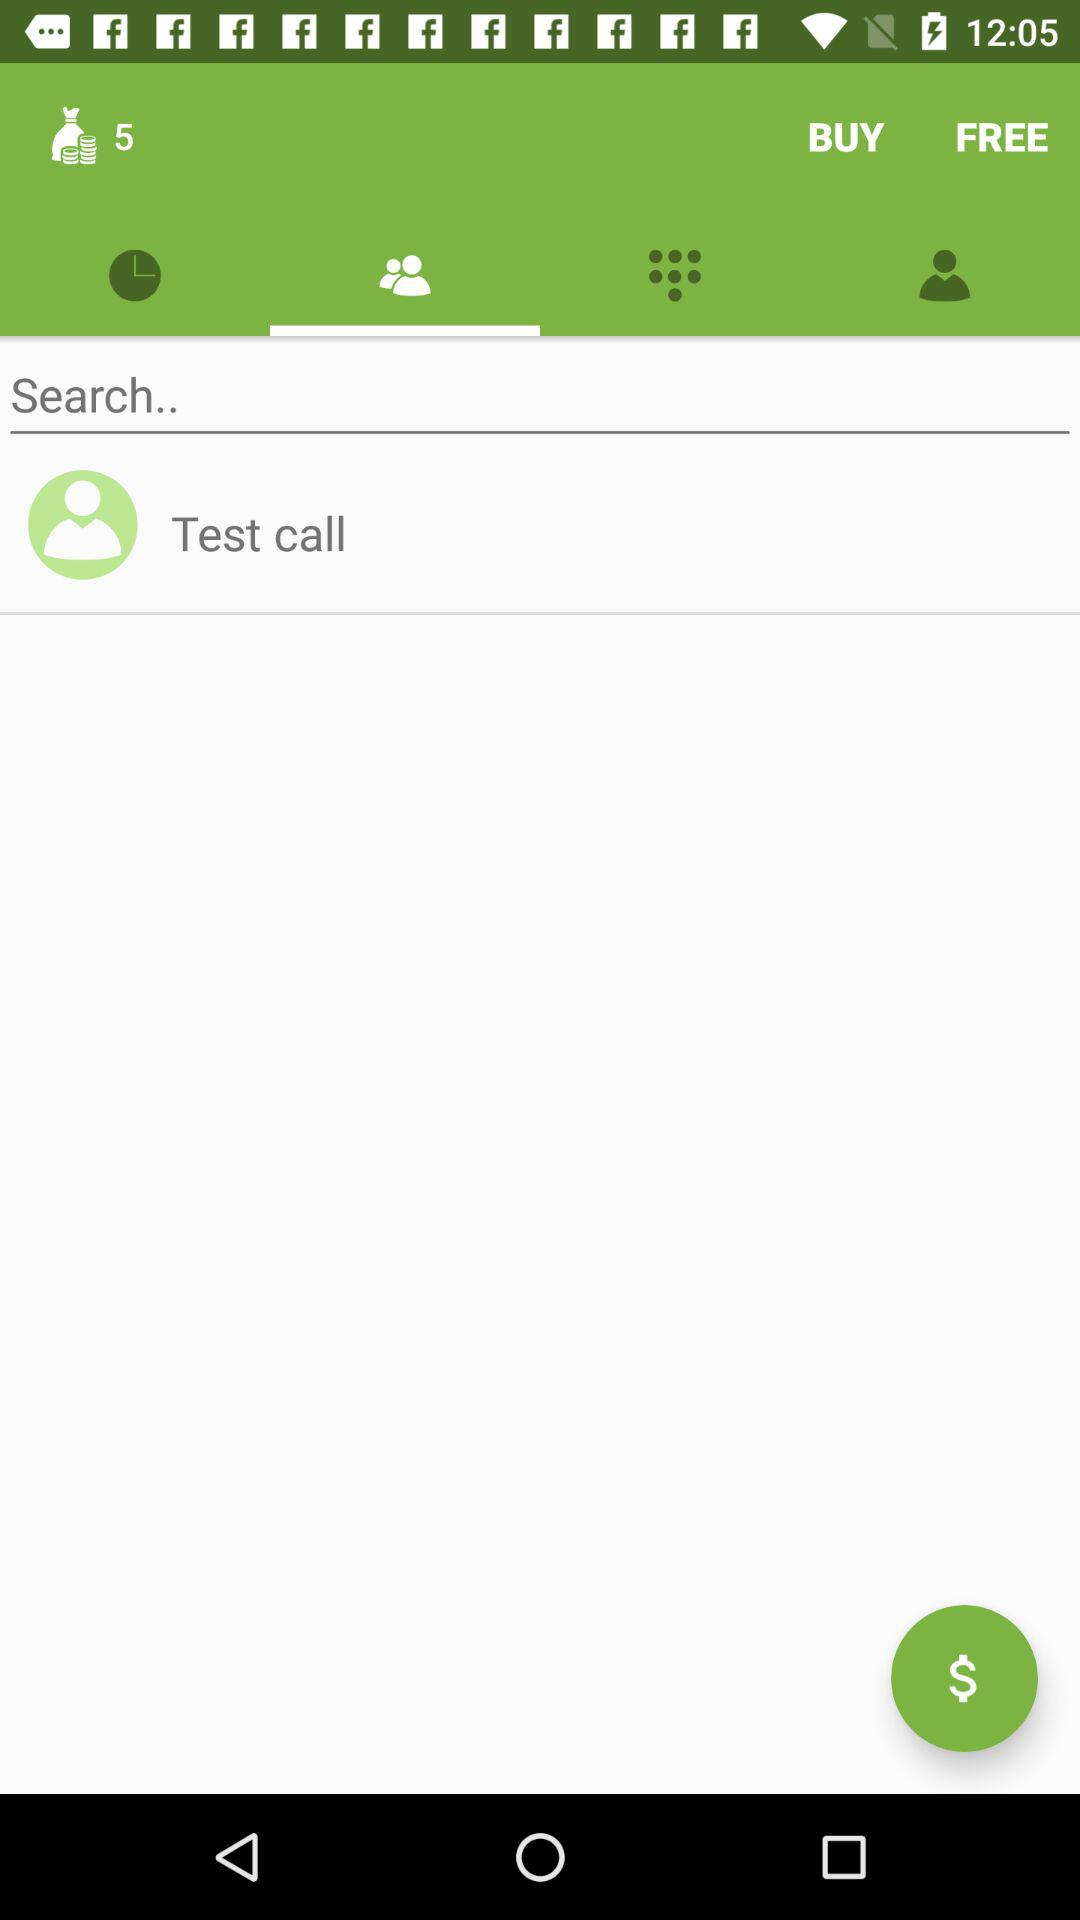Which tab is selected? The selected tab is "Contacts". 